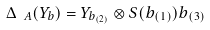Convert formula to latex. <formula><loc_0><loc_0><loc_500><loc_500>\Delta _ { \ A } ( Y _ { b } ) = Y _ { b _ { ( 2 ) } } \otimes S ( b _ { ( 1 ) } ) b _ { ( 3 ) }</formula> 